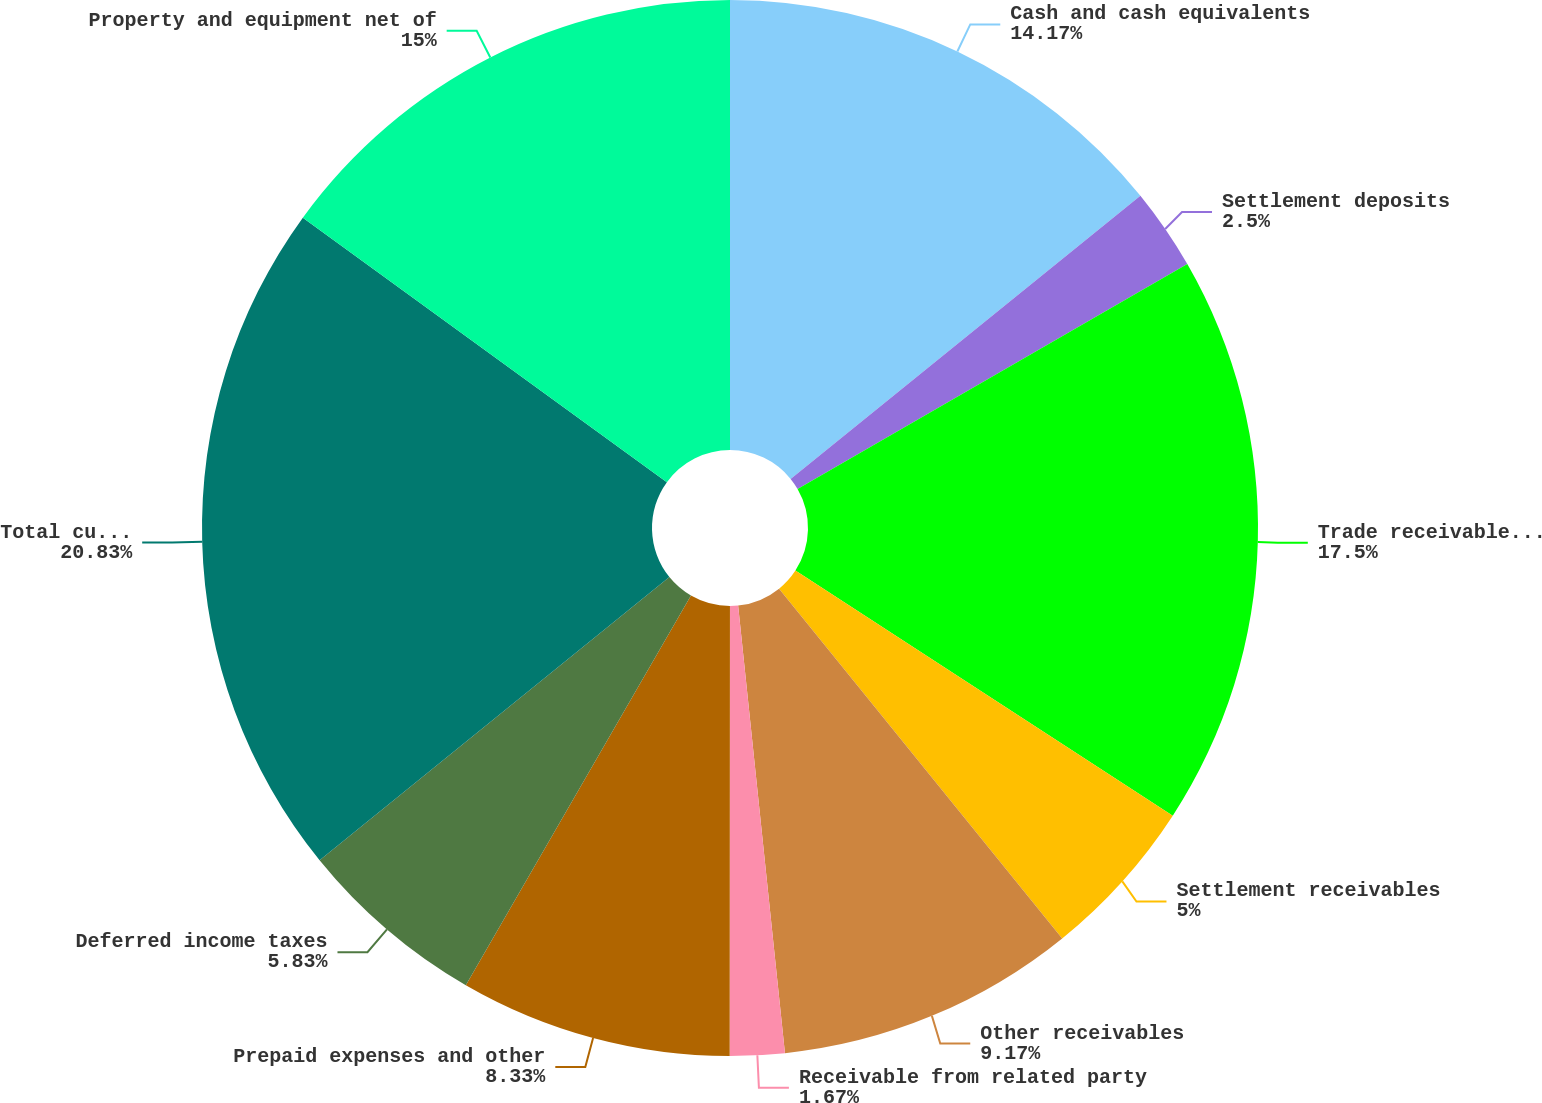<chart> <loc_0><loc_0><loc_500><loc_500><pie_chart><fcel>Cash and cash equivalents<fcel>Settlement deposits<fcel>Trade receivables net of<fcel>Settlement receivables<fcel>Other receivables<fcel>Receivable from related party<fcel>Prepaid expenses and other<fcel>Deferred income taxes<fcel>Total current assets<fcel>Property and equipment net of<nl><fcel>14.17%<fcel>2.5%<fcel>17.5%<fcel>5.0%<fcel>9.17%<fcel>1.67%<fcel>8.33%<fcel>5.83%<fcel>20.83%<fcel>15.0%<nl></chart> 